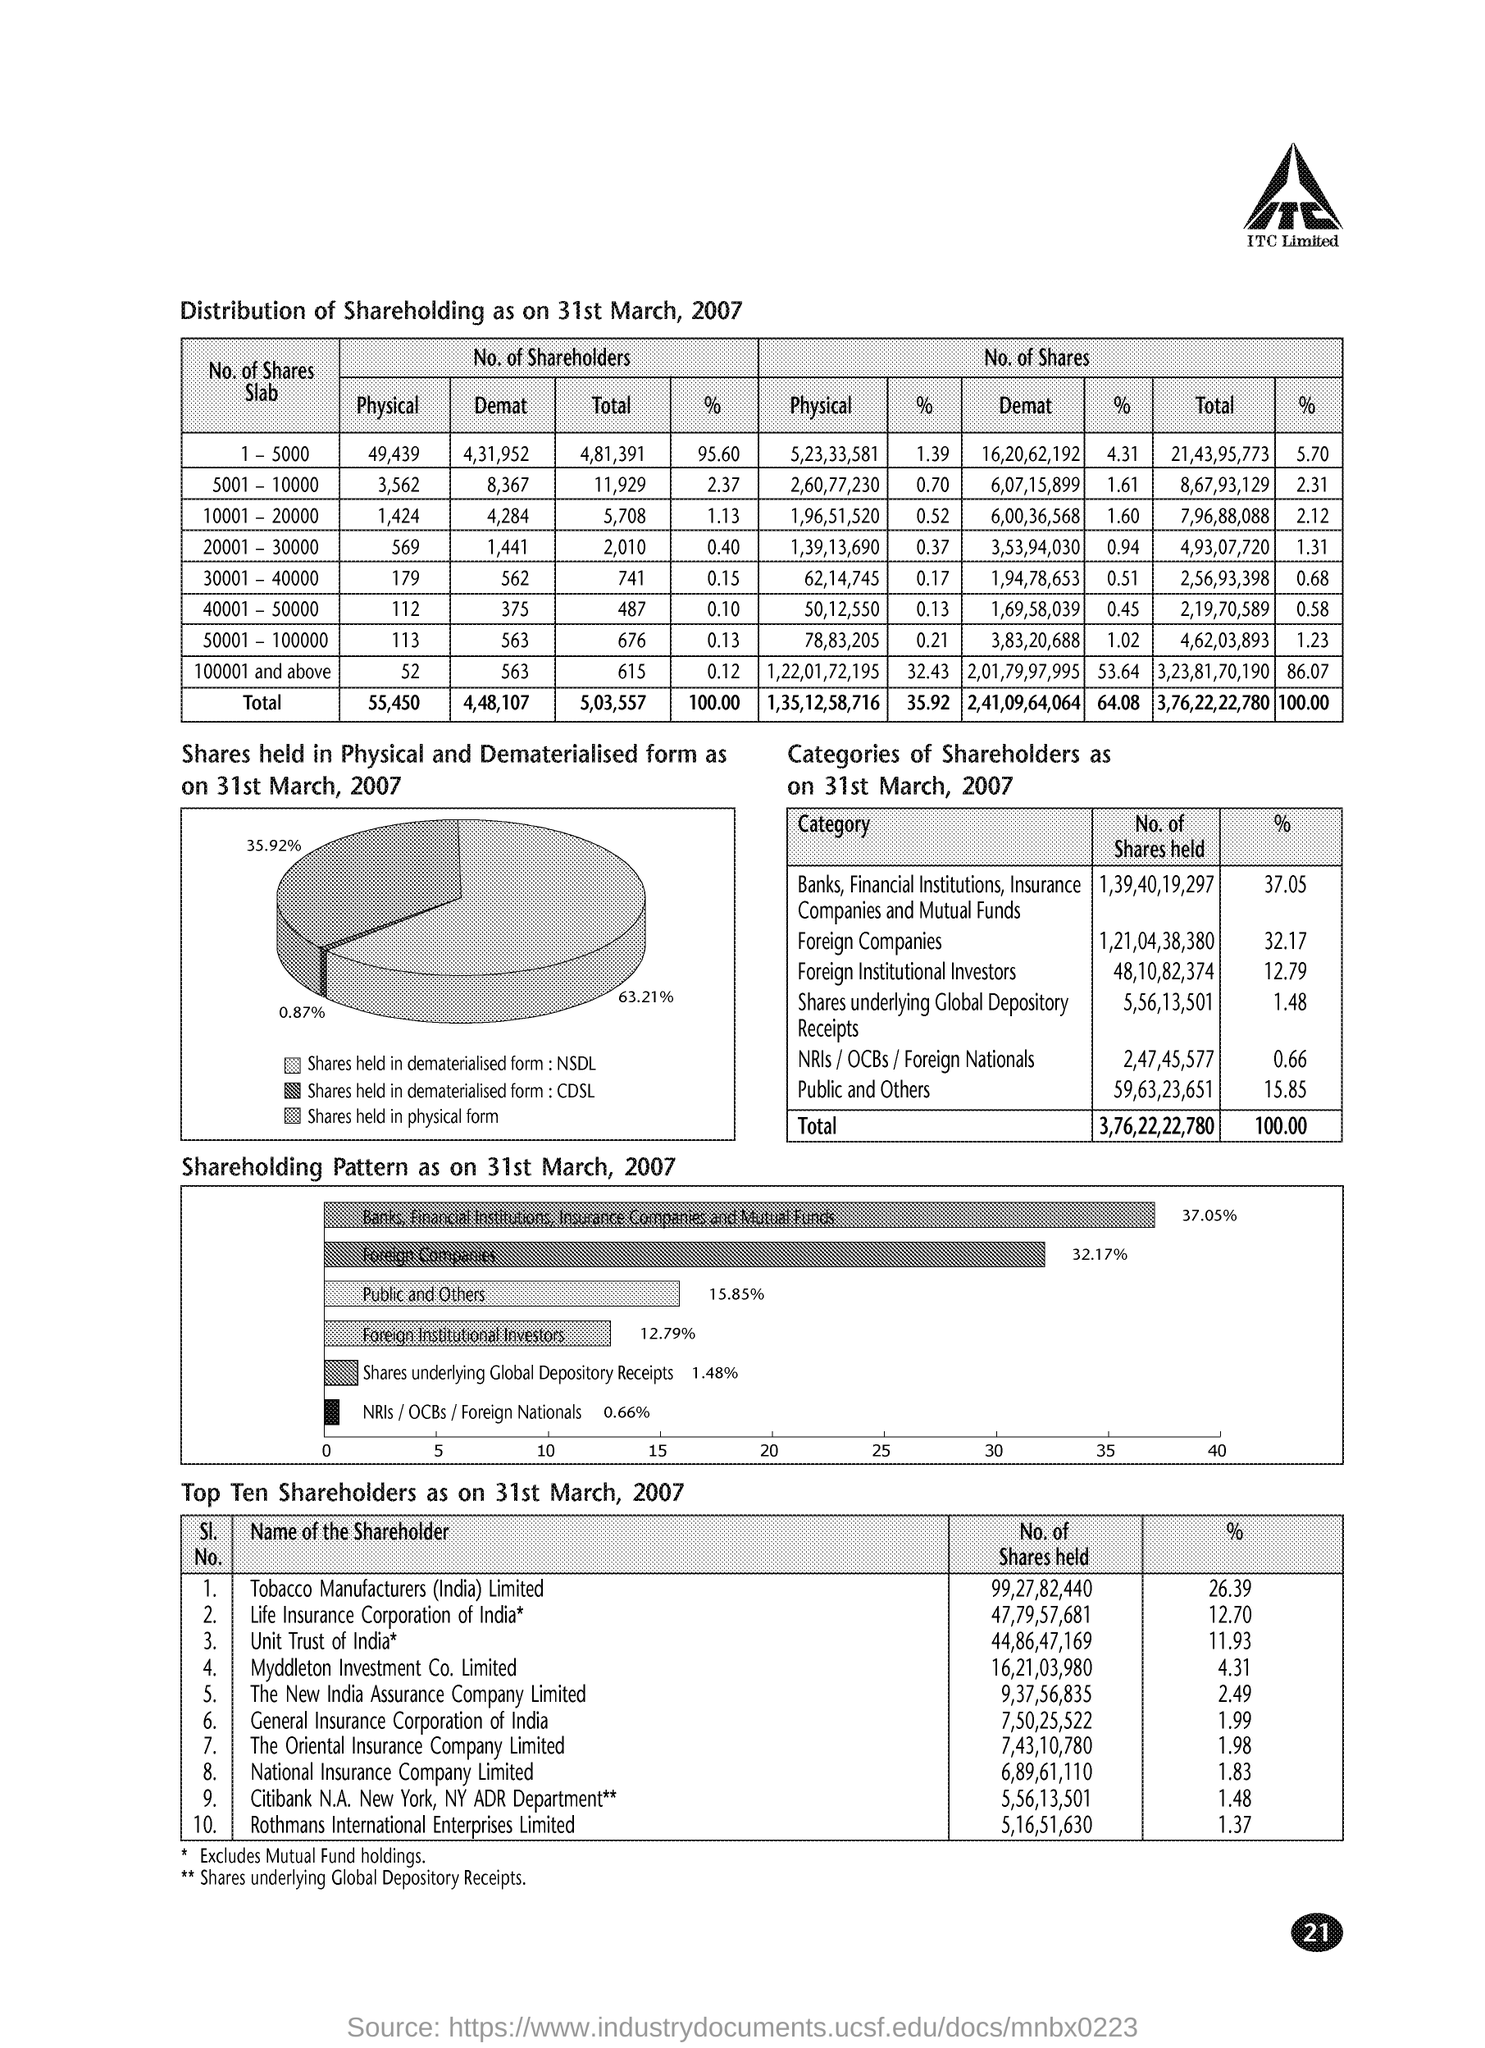What can you tell me about the dematerialization of shares? Dematerialization refers to the process of converting physical shares into electronic form. In the image, as of 31st March, 2007, 62.31% of the shares are held in dematerialized form through NSDL (National Securities Depository Limited), 35.92% through CDSL (Central Depository Services Limited), and a minimal 0.87% of shares remain in physical form. This demonstrates a strong trend towards dematerialization, which makes transaction and handling of shares more efficient. 